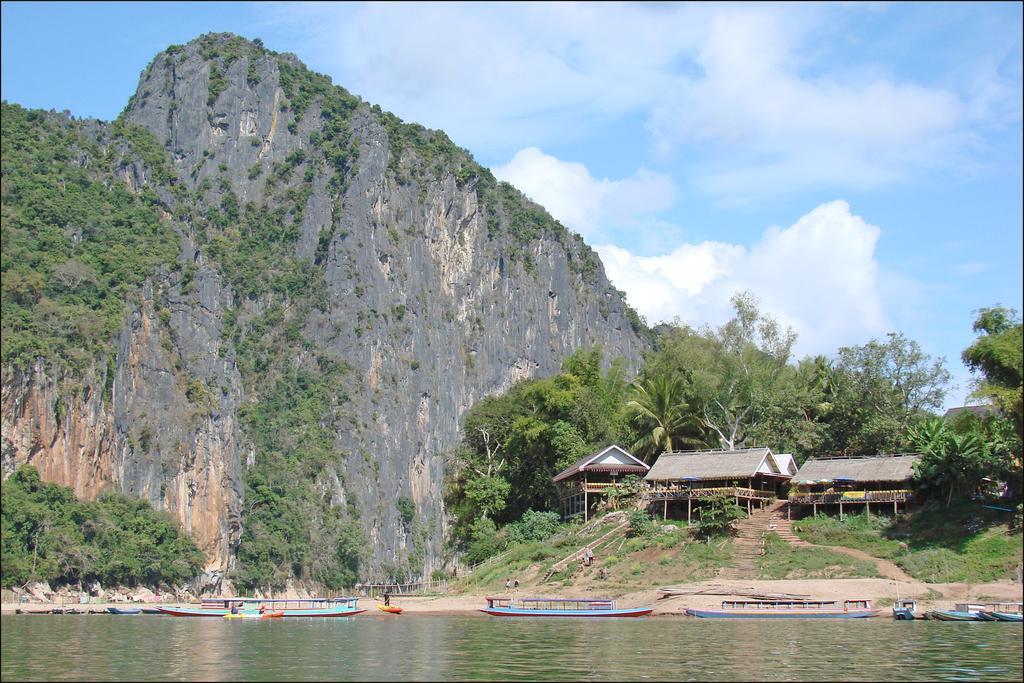Can you describe this image briefly? In the image I can see a beach in which there are some boats and also I can see some huts and a hill on which there are some trees and plants. 